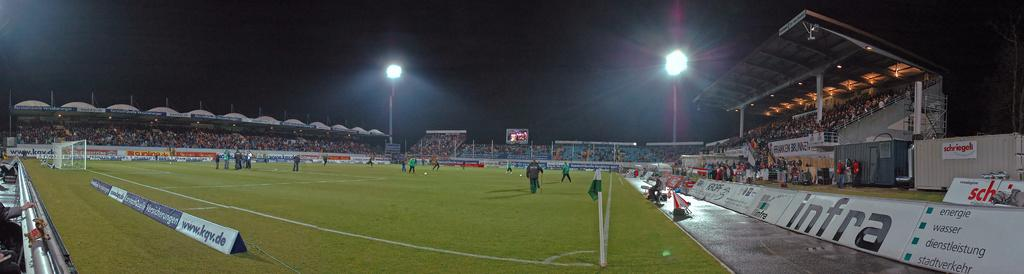Provide a one-sentence caption for the provided image. A stadium with advertising for infra and www.kqv.de. 